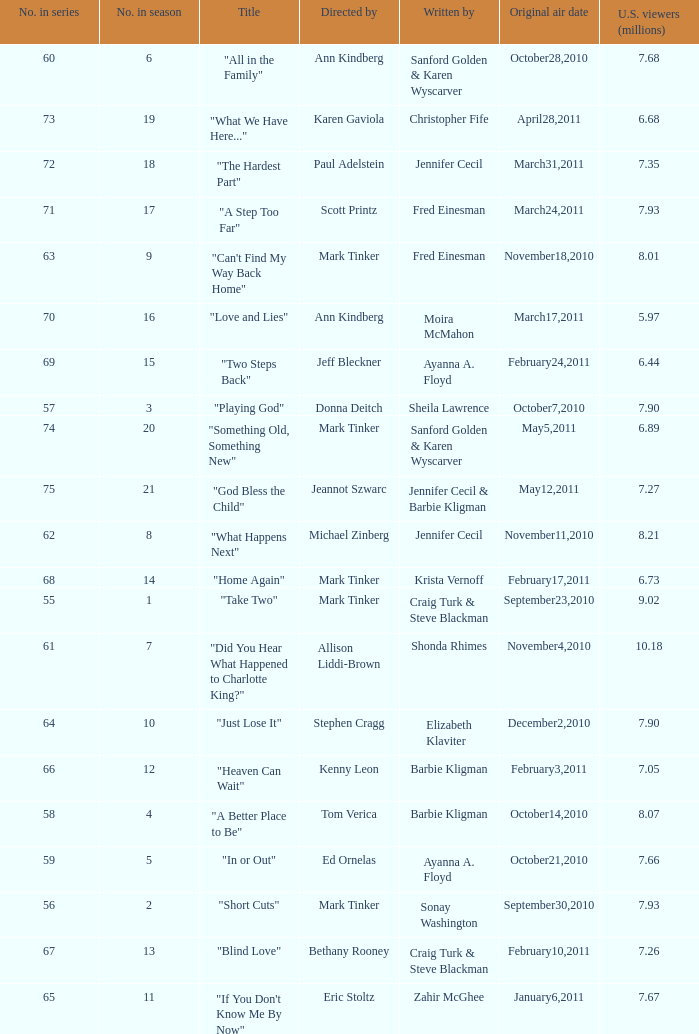Help me parse the entirety of this table. {'header': ['No. in series', 'No. in season', 'Title', 'Directed by', 'Written by', 'Original air date', 'U.S. viewers (millions)'], 'rows': [['60', '6', '"All in the Family"', 'Ann Kindberg', 'Sanford Golden & Karen Wyscarver', 'October28,2010', '7.68'], ['73', '19', '"What We Have Here..."', 'Karen Gaviola', 'Christopher Fife', 'April28,2011', '6.68'], ['72', '18', '"The Hardest Part"', 'Paul Adelstein', 'Jennifer Cecil', 'March31,2011', '7.35'], ['71', '17', '"A Step Too Far"', 'Scott Printz', 'Fred Einesman', 'March24,2011', '7.93'], ['63', '9', '"Can\'t Find My Way Back Home"', 'Mark Tinker', 'Fred Einesman', 'November18,2010', '8.01'], ['70', '16', '"Love and Lies"', 'Ann Kindberg', 'Moira McMahon', 'March17,2011', '5.97'], ['69', '15', '"Two Steps Back"', 'Jeff Bleckner', 'Ayanna A. Floyd', 'February24,2011', '6.44'], ['57', '3', '"Playing God"', 'Donna Deitch', 'Sheila Lawrence', 'October7,2010', '7.90'], ['74', '20', '"Something Old, Something New"', 'Mark Tinker', 'Sanford Golden & Karen Wyscarver', 'May5,2011', '6.89'], ['75', '21', '"God Bless the Child"', 'Jeannot Szwarc', 'Jennifer Cecil & Barbie Kligman', 'May12,2011', '7.27'], ['62', '8', '"What Happens Next"', 'Michael Zinberg', 'Jennifer Cecil', 'November11,2010', '8.21'], ['68', '14', '"Home Again"', 'Mark Tinker', 'Krista Vernoff', 'February17,2011', '6.73'], ['55', '1', '"Take Two"', 'Mark Tinker', 'Craig Turk & Steve Blackman', 'September23,2010', '9.02'], ['61', '7', '"Did You Hear What Happened to Charlotte King?"', 'Allison Liddi-Brown', 'Shonda Rhimes', 'November4,2010', '10.18'], ['64', '10', '"Just Lose It"', 'Stephen Cragg', 'Elizabeth Klaviter', 'December2,2010', '7.90'], ['66', '12', '"Heaven Can Wait"', 'Kenny Leon', 'Barbie Kligman', 'February3,2011', '7.05'], ['58', '4', '"A Better Place to Be"', 'Tom Verica', 'Barbie Kligman', 'October14,2010', '8.07'], ['59', '5', '"In or Out"', 'Ed Ornelas', 'Ayanna A. Floyd', 'October21,2010', '7.66'], ['56', '2', '"Short Cuts"', 'Mark Tinker', 'Sonay Washington', 'September30,2010', '7.93'], ['67', '13', '"Blind Love"', 'Bethany Rooney', 'Craig Turk & Steve Blackman', 'February10,2011', '7.26'], ['65', '11', '"If You Don\'t Know Me By Now"', 'Eric Stoltz', 'Zahir McGhee', 'January6,2011', '7.67']]} What is the earliest numbered episode of the season? 1.0. 